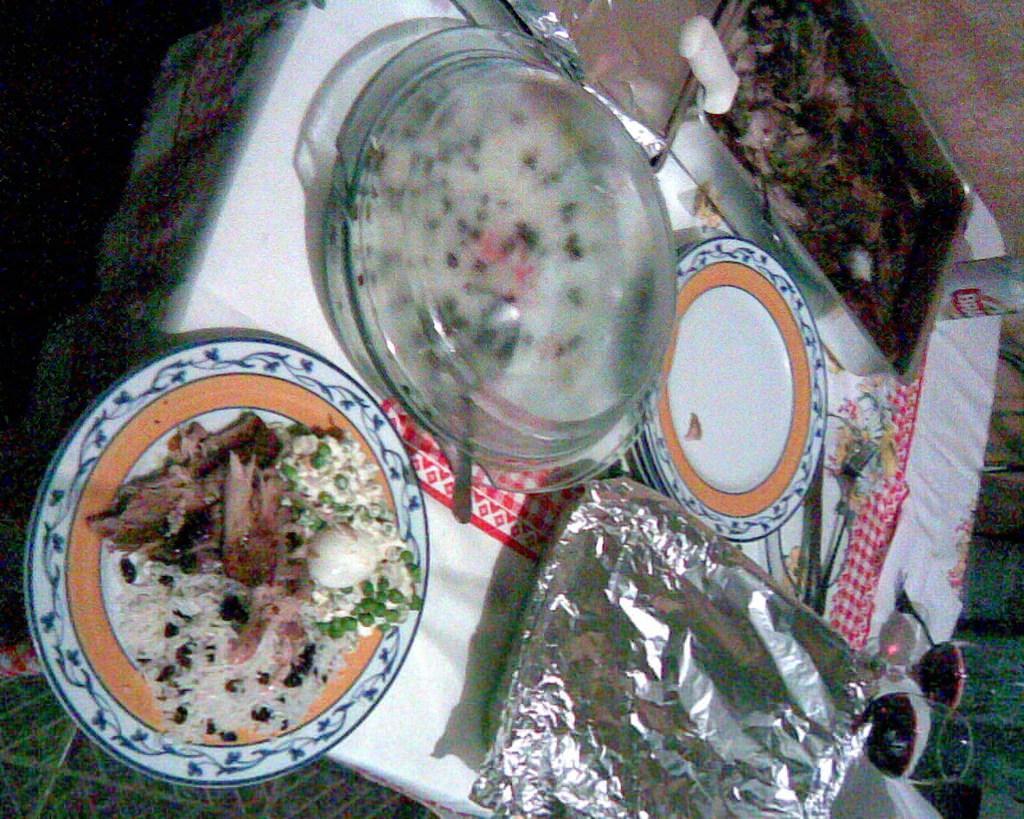How would you summarize this image in a sentence or two? In this picture we can see a table on the ground, on this table we can see a cloth, plates, food, bowl, trays, forks, aluminum foils and a coke tin. 